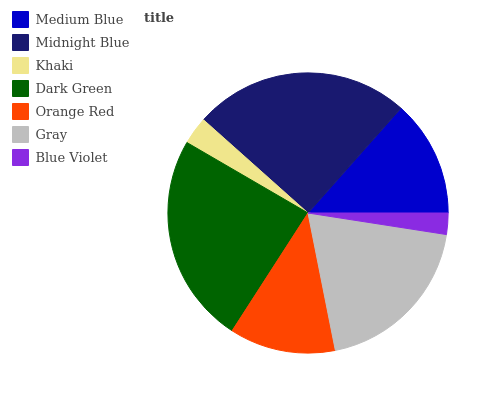Is Blue Violet the minimum?
Answer yes or no. Yes. Is Midnight Blue the maximum?
Answer yes or no. Yes. Is Khaki the minimum?
Answer yes or no. No. Is Khaki the maximum?
Answer yes or no. No. Is Midnight Blue greater than Khaki?
Answer yes or no. Yes. Is Khaki less than Midnight Blue?
Answer yes or no. Yes. Is Khaki greater than Midnight Blue?
Answer yes or no. No. Is Midnight Blue less than Khaki?
Answer yes or no. No. Is Medium Blue the high median?
Answer yes or no. Yes. Is Medium Blue the low median?
Answer yes or no. Yes. Is Midnight Blue the high median?
Answer yes or no. No. Is Orange Red the low median?
Answer yes or no. No. 